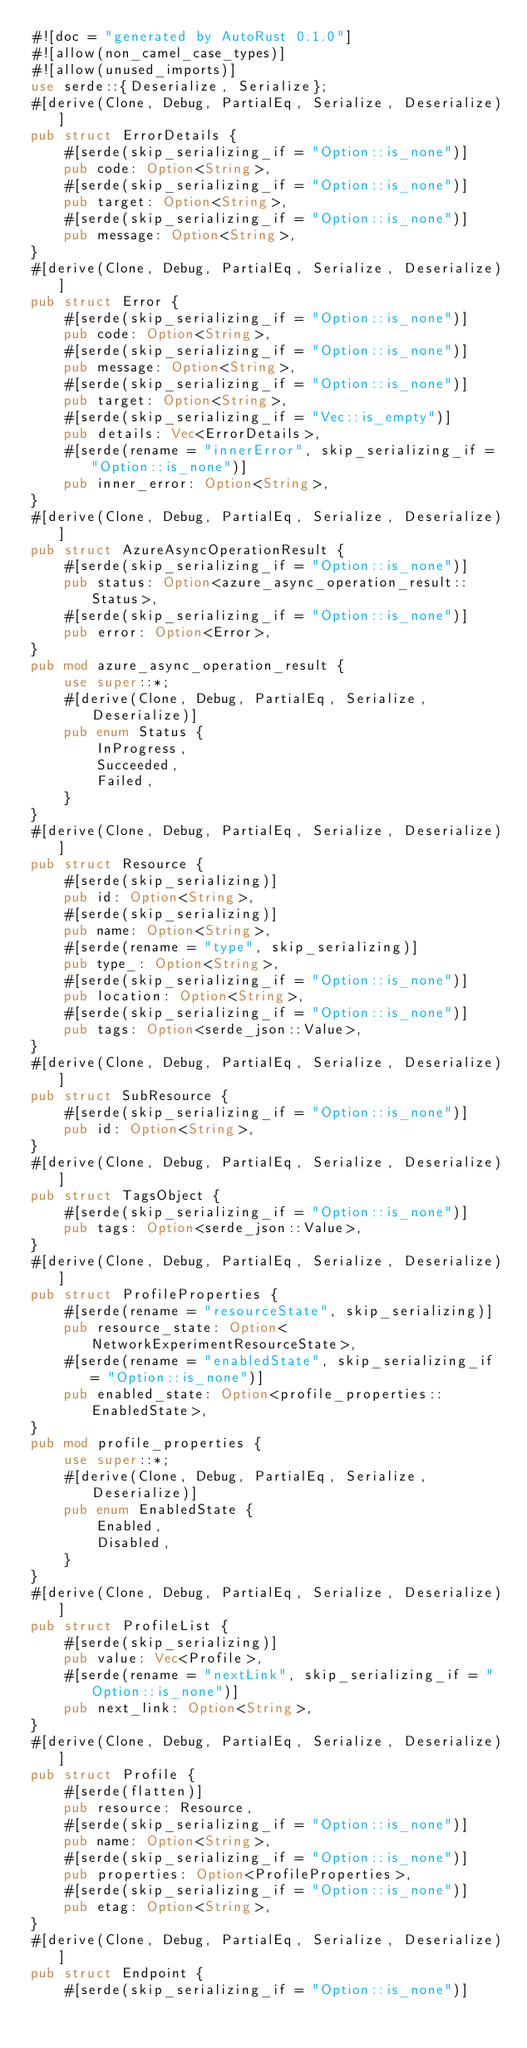<code> <loc_0><loc_0><loc_500><loc_500><_Rust_>#![doc = "generated by AutoRust 0.1.0"]
#![allow(non_camel_case_types)]
#![allow(unused_imports)]
use serde::{Deserialize, Serialize};
#[derive(Clone, Debug, PartialEq, Serialize, Deserialize)]
pub struct ErrorDetails {
    #[serde(skip_serializing_if = "Option::is_none")]
    pub code: Option<String>,
    #[serde(skip_serializing_if = "Option::is_none")]
    pub target: Option<String>,
    #[serde(skip_serializing_if = "Option::is_none")]
    pub message: Option<String>,
}
#[derive(Clone, Debug, PartialEq, Serialize, Deserialize)]
pub struct Error {
    #[serde(skip_serializing_if = "Option::is_none")]
    pub code: Option<String>,
    #[serde(skip_serializing_if = "Option::is_none")]
    pub message: Option<String>,
    #[serde(skip_serializing_if = "Option::is_none")]
    pub target: Option<String>,
    #[serde(skip_serializing_if = "Vec::is_empty")]
    pub details: Vec<ErrorDetails>,
    #[serde(rename = "innerError", skip_serializing_if = "Option::is_none")]
    pub inner_error: Option<String>,
}
#[derive(Clone, Debug, PartialEq, Serialize, Deserialize)]
pub struct AzureAsyncOperationResult {
    #[serde(skip_serializing_if = "Option::is_none")]
    pub status: Option<azure_async_operation_result::Status>,
    #[serde(skip_serializing_if = "Option::is_none")]
    pub error: Option<Error>,
}
pub mod azure_async_operation_result {
    use super::*;
    #[derive(Clone, Debug, PartialEq, Serialize, Deserialize)]
    pub enum Status {
        InProgress,
        Succeeded,
        Failed,
    }
}
#[derive(Clone, Debug, PartialEq, Serialize, Deserialize)]
pub struct Resource {
    #[serde(skip_serializing)]
    pub id: Option<String>,
    #[serde(skip_serializing)]
    pub name: Option<String>,
    #[serde(rename = "type", skip_serializing)]
    pub type_: Option<String>,
    #[serde(skip_serializing_if = "Option::is_none")]
    pub location: Option<String>,
    #[serde(skip_serializing_if = "Option::is_none")]
    pub tags: Option<serde_json::Value>,
}
#[derive(Clone, Debug, PartialEq, Serialize, Deserialize)]
pub struct SubResource {
    #[serde(skip_serializing_if = "Option::is_none")]
    pub id: Option<String>,
}
#[derive(Clone, Debug, PartialEq, Serialize, Deserialize)]
pub struct TagsObject {
    #[serde(skip_serializing_if = "Option::is_none")]
    pub tags: Option<serde_json::Value>,
}
#[derive(Clone, Debug, PartialEq, Serialize, Deserialize)]
pub struct ProfileProperties {
    #[serde(rename = "resourceState", skip_serializing)]
    pub resource_state: Option<NetworkExperimentResourceState>,
    #[serde(rename = "enabledState", skip_serializing_if = "Option::is_none")]
    pub enabled_state: Option<profile_properties::EnabledState>,
}
pub mod profile_properties {
    use super::*;
    #[derive(Clone, Debug, PartialEq, Serialize, Deserialize)]
    pub enum EnabledState {
        Enabled,
        Disabled,
    }
}
#[derive(Clone, Debug, PartialEq, Serialize, Deserialize)]
pub struct ProfileList {
    #[serde(skip_serializing)]
    pub value: Vec<Profile>,
    #[serde(rename = "nextLink", skip_serializing_if = "Option::is_none")]
    pub next_link: Option<String>,
}
#[derive(Clone, Debug, PartialEq, Serialize, Deserialize)]
pub struct Profile {
    #[serde(flatten)]
    pub resource: Resource,
    #[serde(skip_serializing_if = "Option::is_none")]
    pub name: Option<String>,
    #[serde(skip_serializing_if = "Option::is_none")]
    pub properties: Option<ProfileProperties>,
    #[serde(skip_serializing_if = "Option::is_none")]
    pub etag: Option<String>,
}
#[derive(Clone, Debug, PartialEq, Serialize, Deserialize)]
pub struct Endpoint {
    #[serde(skip_serializing_if = "Option::is_none")]</code> 